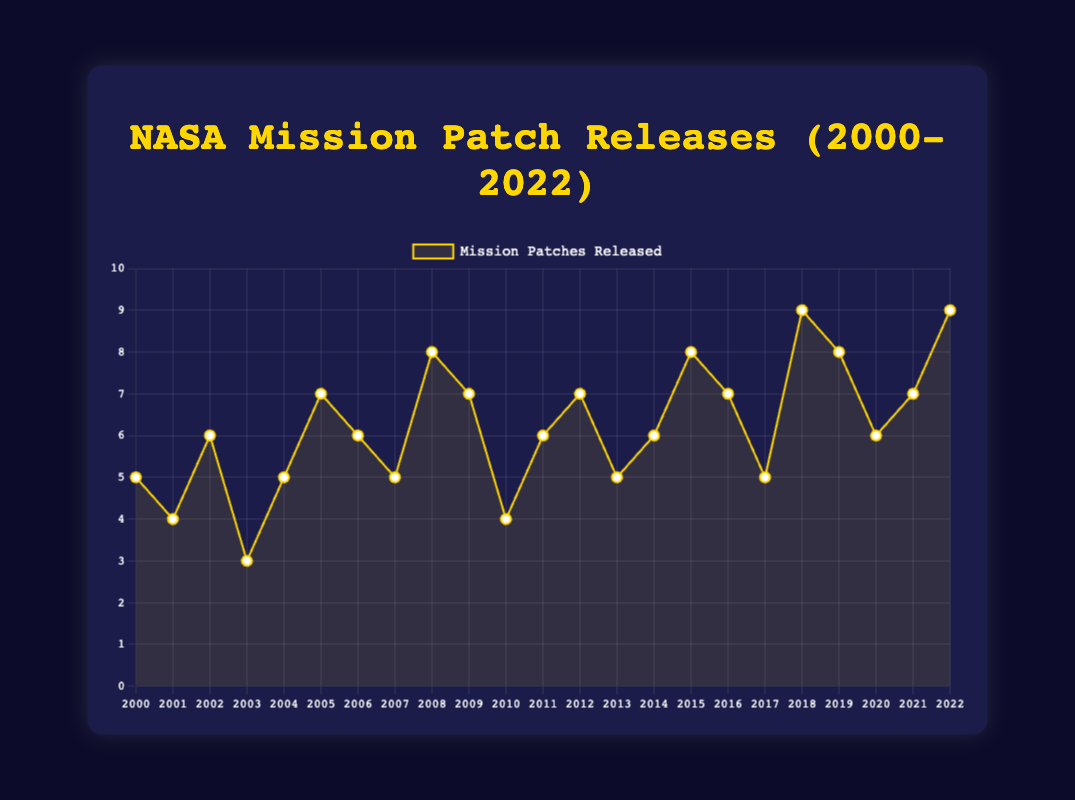Which year had the highest number of mission patches released? To determine this, we look for the peak value on the line plot. The highest number of patches released is 9, which occurs in 2018 and 2022.
Answer: 2018, 2022 Which year had the lowest number of mission patches released? The lowest point on the line plot indicates the year with the least number of patches released. The lowest number is 3, which occurs in 2003.
Answer: 2003 What is the average number of mission patches released per year between 2000 and 2022? To find the average, sum the number of patches released each year and divide by the number of years. The total is 143 (5 + 4 + 6 + 3 + 5 + 7 + 6 + 5 + 8 + 7 + 4 + 6 + 7 + 5 + 6 + 8 + 7 + 5 + 9 + 8 + 6 + 7 + 9). There are 23 years, so the average is 143/23 ≈ 6.22.
Answer: ~6.22 How many times did NASA release exactly 5 mission patches in a year? Examine the line plot to count the number of times the value 5 appears. It appears in 2000, 2004, 2007, 2013, and 2017.
Answer: 5 In which years did NASA release more patches compared to the previous year? To answer this, compare the number of patches released each year to the previous year's value: 2002 (6>4), 2005 (7>5), 2008 (8>5), 2009 (7>4), 2011 (6>4), 2012 (7>6), 2014 (6>5), 2015 (8>6), 2016 (7>5), 2018 (9>5), 2019 (8>6), 2021 (7>6), 2022 (9>7).
Answer: 2002, 2005, 2008, 2009, 2011, 2012, 2014, 2015, 2016, 2018, 2019, 2021, 2022 Which year had the same number of patches released as in 2011? Find the value for 2011, which is 6, and then identify the years with the same value. The value 6 appears in 2002, 2006, 2011, 2014, and 2020.
Answer: 2002, 2006, 2014, 2020 By how much did the number of mission patches released increase from 2003 to 2004? Subtract the value of patches released in 2003 (3) from that in 2004 (5). 5 - 3 = 2
Answer: 2 What is the median number of patches released from 2000 to 2022? Sort the numbers of patches: 3, 4, 4, 5, 5, 5, 5, 5, 6, 6, 6, 6, 6, 7, 7, 7, 7, 7, 8, 8, 8, 9, 9. Count the values (23) and find the middle one, which is the 12th value (6).
Answer: 6 How many years saw a decrease in the number of patches released compared to the previous year? Compare consecutive years and count decreases: 2001 (4<5), 2003 (3<6), 2007 (5<6), 2010 (4<7), 2013 (5<7), 2017 (5<7), 2020 (6<8).
Answer: 7 Compare the number of mission patches released in 2000 and 2022. Examine the numbers for 2000 (5) and 2022 (9). 2022 has 4 more patches than 2000.
Answer: 2022 has 4 more 